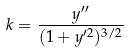Convert formula to latex. <formula><loc_0><loc_0><loc_500><loc_500>k = \frac { y ^ { \prime \prime } } { ( 1 + y ^ { \prime 2 } ) ^ { 3 / 2 } }</formula> 